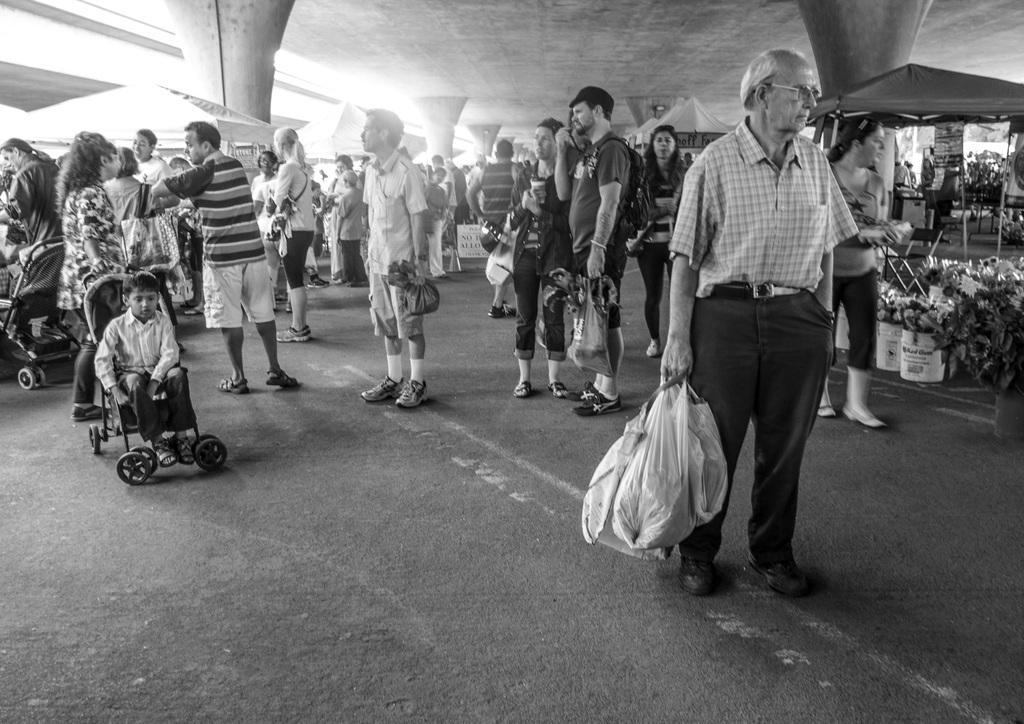Could you give a brief overview of what you see in this image? In this picture I can see so many people are standing under the roof and holding bags, side I can see some tents. 